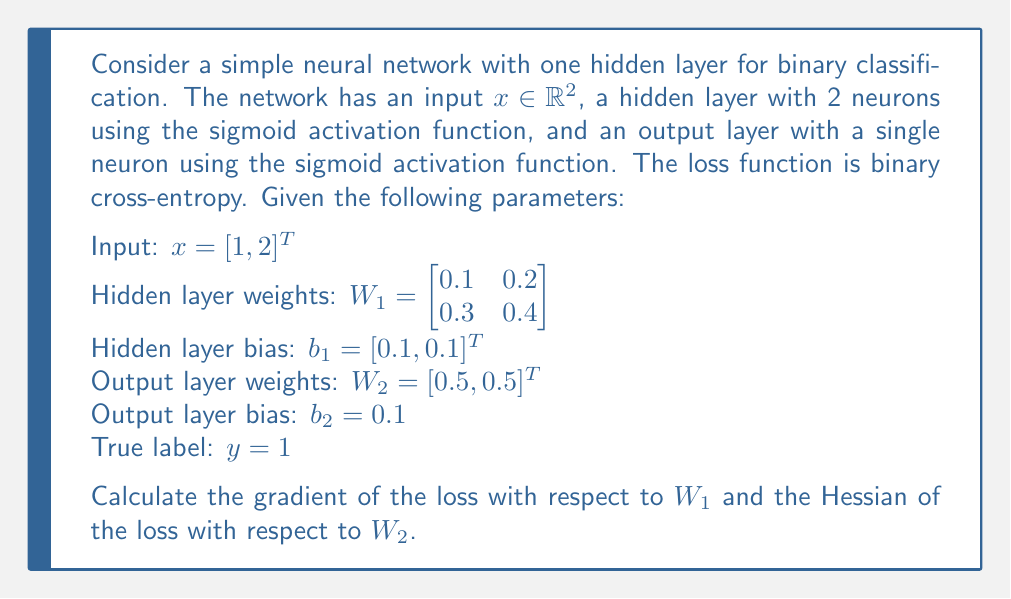Solve this math problem. Let's approach this step-by-step:

1) First, we need to perform forward propagation:

   Hidden layer output: $h = \sigma(W_1x + b_1)$
   $$h_1 = \sigma(0.1 \cdot 1 + 0.2 \cdot 2 + 0.1) = \sigma(0.6) = 0.6457$$
   $$h_2 = \sigma(0.3 \cdot 1 + 0.4 \cdot 2 + 0.1) = \sigma(1.2) = 0.7685$$

   Output: $\hat{y} = \sigma(W_2^T h + b_2)$
   $$\hat{y} = \sigma(0.5 \cdot 0.6457 + 0.5 \cdot 0.7685 + 0.1) = \sigma(0.8071) = 0.6915$$

2) The binary cross-entropy loss is:
   $$L = -y \log(\hat{y}) - (1-y) \log(1-\hat{y}) = -\log(0.6915) = 0.3688$$

3) To calculate the gradient of L with respect to $W_1$, we use the chain rule:

   $$\frac{\partial L}{\partial W_1} = \frac{\partial L}{\partial \hat{y}} \cdot \frac{\partial \hat{y}}{\partial h} \cdot \frac{\partial h}{\partial W_1}$$

   $$\frac{\partial L}{\partial \hat{y}} = -\frac{y}{\hat{y}} + \frac{1-y}{1-\hat{y}} = -\frac{1}{0.6915} + \frac{0}{0.3085} = -1.4461$$

   $$\frac{\partial \hat{y}}{\partial h} = W_2^T \cdot \hat{y}(1-\hat{y}) = [0.5, 0.5] \cdot 0.6915 \cdot 0.3085 = [0.1068, 0.1068]$$

   $$\frac{\partial h}{\partial W_1} = x^T \cdot h(1-h) = \begin{bmatrix} 1 \cdot 0.6457 \cdot 0.3543 & 2 \cdot 0.6457 \cdot 0.3543 \\ 1 \cdot 0.7685 \cdot 0.2315 & 2 \cdot 0.7685 \cdot 0.2315 \end{bmatrix}$$

   Multiplying these together gives:

   $$\frac{\partial L}{\partial W_1} = \begin{bmatrix} -0.0348 & -0.0696 \\ -0.0379 & -0.0758 \end{bmatrix}$$

4) For the Hessian of L with respect to $W_2$, we need to calculate:

   $$H = \frac{\partial^2 L}{\partial W_2^2} = \frac{\partial}{\partial W_2} (\frac{\partial L}{\partial W_2})$$

   $$\frac{\partial L}{\partial W_2} = \frac{\partial L}{\partial \hat{y}} \cdot \frac{\partial \hat{y}}{\partial W_2} = -1.4461 \cdot h \cdot \hat{y}(1-\hat{y})$$
   
   $$= -1.4461 \cdot [0.6457, 0.7685] \cdot 0.6915 \cdot 0.3085 = [-0.0890, -0.1060]$$

   Now, differentiating again:

   $$H = \frac{\partial^2 L}{\partial W_2^2} = h^T h \cdot \hat{y}(1-\hat{y})(1-2\hat{y})$$

   $$= \begin{bmatrix} 0.6457^2 & 0.6457 \cdot 0.7685 \\ 0.7685 \cdot 0.6457 & 0.7685^2 \end{bmatrix} \cdot 0.6915 \cdot 0.3085 \cdot (1-2 \cdot 0.6915)$$

   $$= \begin{bmatrix} 0.0275 & 0.0328 \\ 0.0328 & 0.0390 \end{bmatrix}$$
Answer: $\frac{\partial L}{\partial W_1} = \begin{bmatrix} -0.0348 & -0.0696 \\ -0.0379 & -0.0758 \end{bmatrix}$, $H = \begin{bmatrix} 0.0275 & 0.0328 \\ 0.0328 & 0.0390 \end{bmatrix}$ 